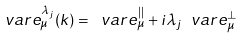<formula> <loc_0><loc_0><loc_500><loc_500>\ v a r e ^ { \lambda _ { j } } _ { \mu } ( k ) = \ v a r e _ { \mu } ^ { | | } + i { \lambda _ { j } } \ v a r e _ { \mu } ^ { \bot }</formula> 